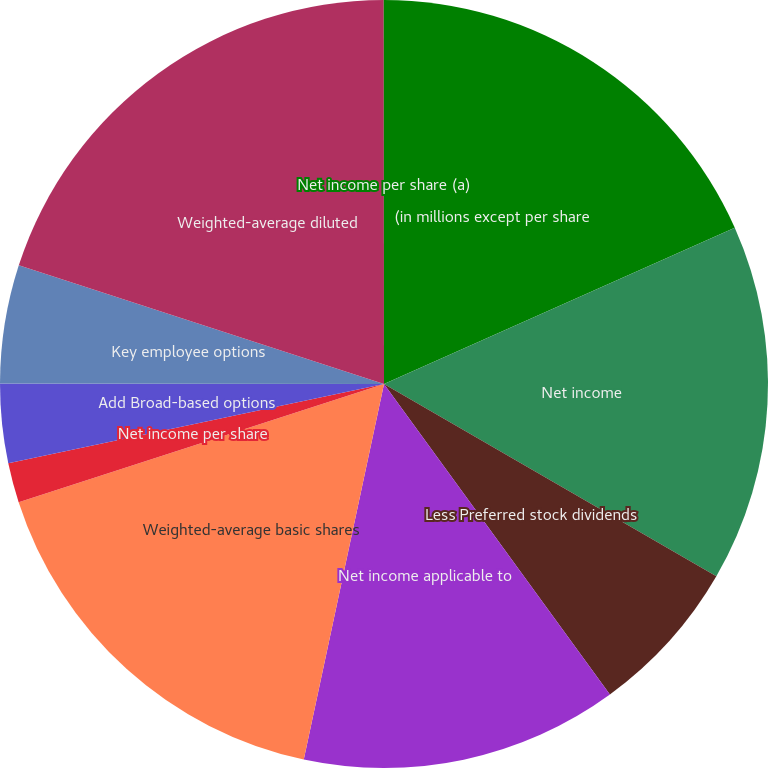Convert chart. <chart><loc_0><loc_0><loc_500><loc_500><pie_chart><fcel>(in millions except per share<fcel>Net income<fcel>Less Preferred stock dividends<fcel>Net income applicable to<fcel>Weighted-average basic shares<fcel>Net income per share<fcel>Add Broad-based options<fcel>Key employee options<fcel>Weighted-average diluted<fcel>Net income per share (a)<nl><fcel>18.33%<fcel>15.02%<fcel>6.64%<fcel>13.36%<fcel>16.67%<fcel>1.67%<fcel>3.33%<fcel>4.98%<fcel>19.99%<fcel>0.01%<nl></chart> 